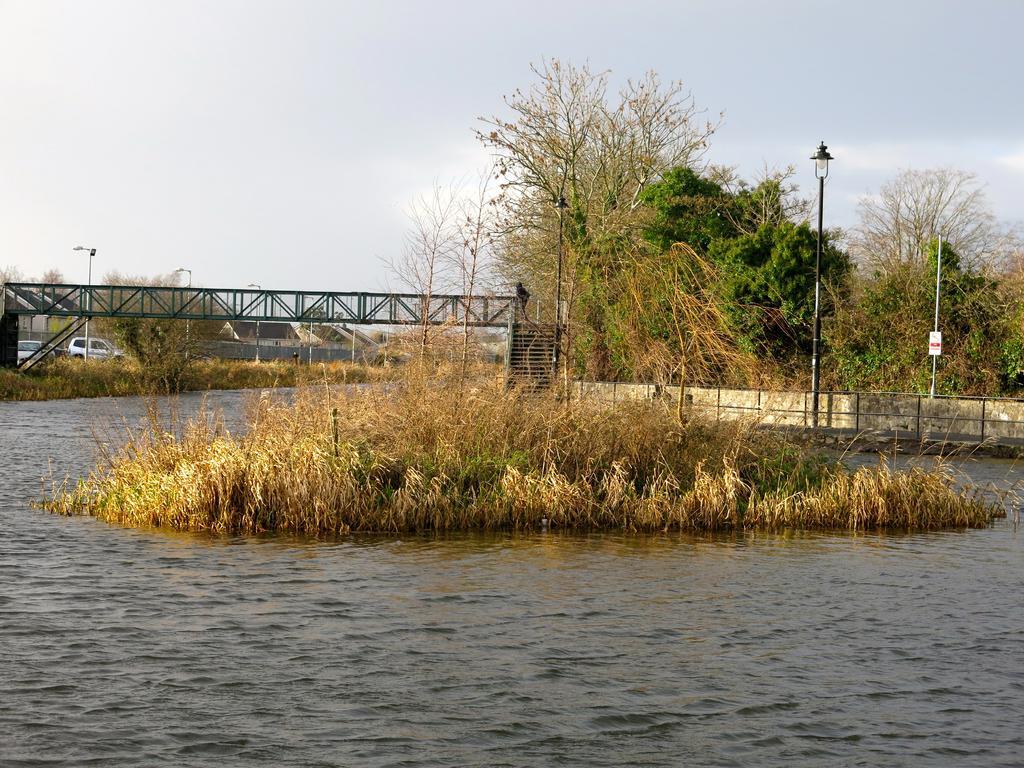Describe this image in one or two sentences. The picture is clicked in a river where there is dry grass in the center of the river and in the background we observe a bridge , few cars and trees. 